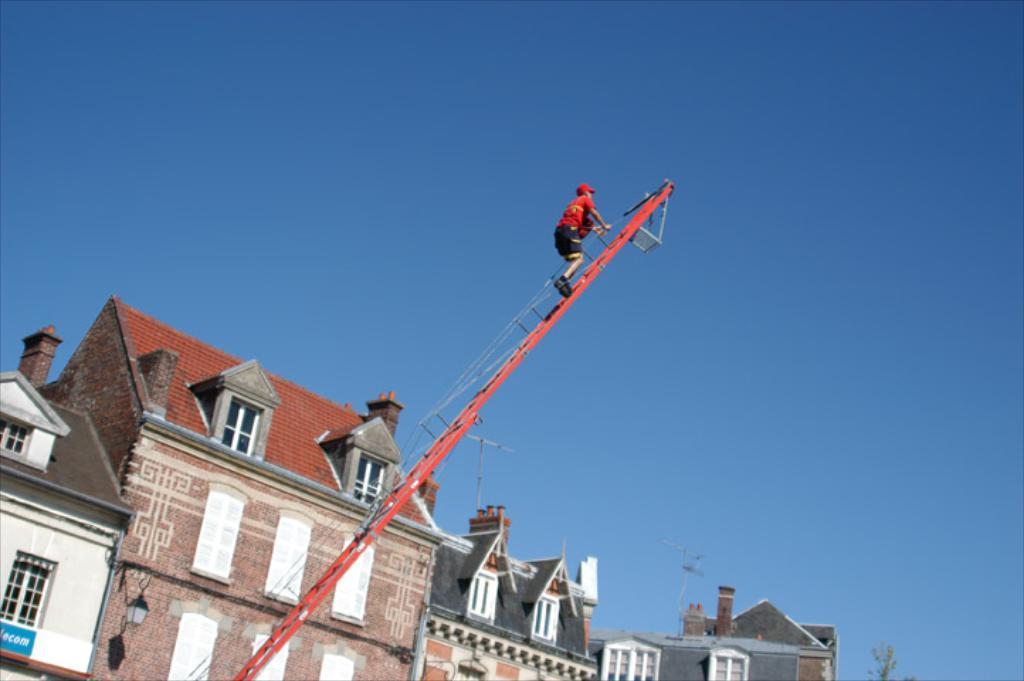Please provide a concise description of this image. In this image we can see a person on a metal ladder holding the ropes. We can also see some buildings with windows and street lamps, a tree and the sky which looks cloudy. 